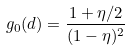<formula> <loc_0><loc_0><loc_500><loc_500>g _ { 0 } ( d ) = \frac { 1 + \eta / 2 } { ( 1 - \eta ) ^ { 2 } }</formula> 